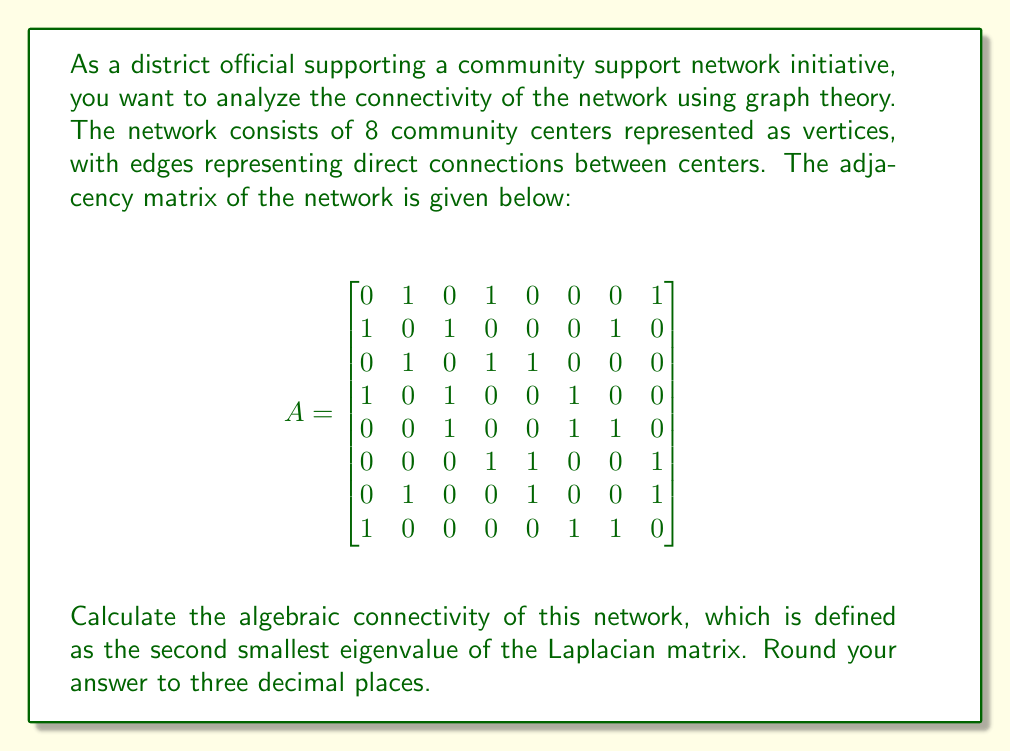Show me your answer to this math problem. To solve this problem, we need to follow these steps:

1. Calculate the degree matrix D.
2. Calculate the Laplacian matrix L = D - A.
3. Find the eigenvalues of L.
4. Identify the second smallest eigenvalue (algebraic connectivity).

Step 1: Calculate the degree matrix D
The degree of each vertex is the sum of its row (or column) in the adjacency matrix:

$$
D = \begin{bmatrix}
3 & 0 & 0 & 0 & 0 & 0 & 0 & 0 \\
0 & 3 & 0 & 0 & 0 & 0 & 0 & 0 \\
0 & 0 & 3 & 0 & 0 & 0 & 0 & 0 \\
0 & 0 & 0 & 3 & 0 & 0 & 0 & 0 \\
0 & 0 & 0 & 0 & 3 & 0 & 0 & 0 \\
0 & 0 & 0 & 0 & 0 & 3 & 0 & 0 \\
0 & 0 & 0 & 0 & 0 & 0 & 3 & 0 \\
0 & 0 & 0 & 0 & 0 & 0 & 0 & 3
\end{bmatrix}
$$

Step 2: Calculate the Laplacian matrix L = D - A

$$
L = D - A = \begin{bmatrix}
3 & -1 & 0 & -1 & 0 & 0 & 0 & -1 \\
-1 & 3 & -1 & 0 & 0 & 0 & -1 & 0 \\
0 & -1 & 3 & -1 & -1 & 0 & 0 & 0 \\
-1 & 0 & -1 & 3 & 0 & -1 & 0 & 0 \\
0 & 0 & -1 & 0 & 3 & -1 & -1 & 0 \\
0 & 0 & 0 & -1 & -1 & 3 & 0 & -1 \\
0 & -1 & 0 & 0 & -1 & 0 & 3 & -1 \\
-1 & 0 & 0 & 0 & 0 & -1 & -1 & 3
\end{bmatrix}
$$

Step 3: Find the eigenvalues of L
Using a computer algebra system or numerical methods, we can calculate the eigenvalues of L:

$\lambda_1 \approx 0$
$\lambda_2 \approx 0.586$
$\lambda_3 \approx 1.000$
$\lambda_4 \approx 2.000$
$\lambda_5 \approx 3.000$
$\lambda_6 \approx 3.414$
$\lambda_7 \approx 4.000$
$\lambda_8 \approx 5.000$

Step 4: Identify the second smallest eigenvalue
The second smallest eigenvalue, which is the algebraic connectivity, is $\lambda_2 \approx 0.586$.

Rounding to three decimal places, we get 0.586.
Answer: 0.586 